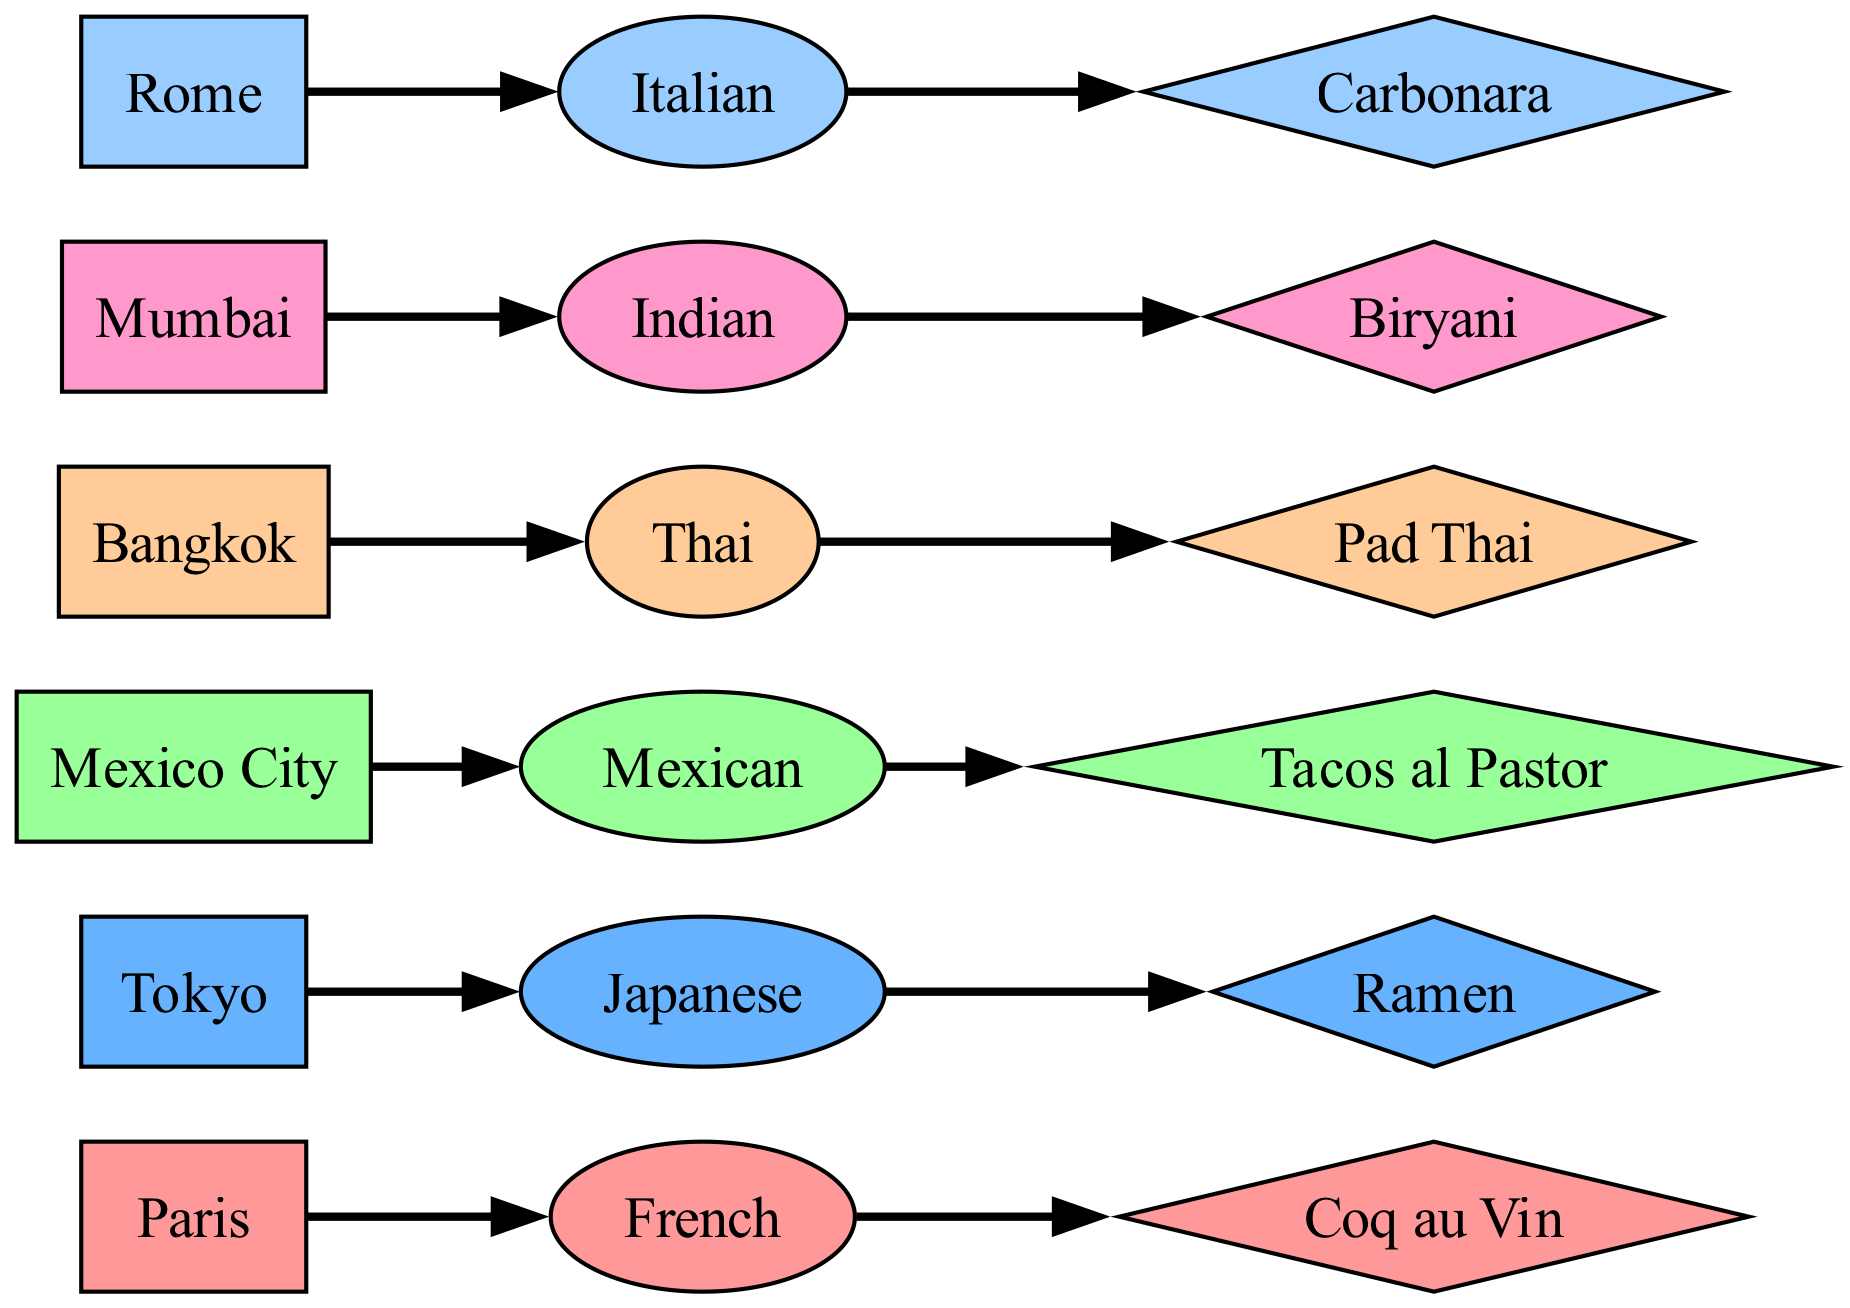What cuisine is represented in Tokyo? The diagram shows a link from Tokyo to the cuisine node labeled "Japanese," indicating that the cuisine represented in Tokyo is Japanese.
Answer: Japanese Which city is known for Coq au Vin? From the diagram, there is a direct connection from Paris to the favorite dish node labeled "Coq au Vin," indicating that Paris is associated with this dish.
Answer: Paris How many favorite dishes are represented in the diagram? By counting the number of favorite dish nodes (Coq au Vin, Ramen, Tacos al Pastor, Pad Thai, Biryani, Carbonara), we find there are six unique favorite dishes represented in the diagram.
Answer: 6 What is the favorite dish of Mumbai? The link between Mumbai and the favorite dish node shows the label "Biryani," indicating that the favorite dish in Mumbai is Biryani.
Answer: Biryani Which cuisine is connected to the favorite dish Pad Thai? The diagram illustrates a connection from the Thai cuisine node to the favorite dish node "Pad Thai," indicating that Pad Thai is the favorite dish related to Thai cuisine.
Answer: Thai Which two cuisines are most connected to favorite dishes in the diagram? Counting the connections leads to the conclusion that each cuisine node (French, Japanese, Mexican, Thai, Indian, Italian) has one connection to a favorite dish. Therefore, no cuisine is more connected than others; all have equal connections.
Answer: All equal How many edges are there in total in the diagram? Each city connects to a cuisine, and each cuisine connects to a favorite dish, making a total of six cities and connections to six cuisines and six favorite dishes. Thus, the number of edges is double the number of cities, resulting in twelve edges in total.
Answer: 12 What is the favorite dish in Rome? The diagram shows a direct link from Rome to the favorite dish node labeled "Carbonara," which indicates that the favorite dish in Rome is Carbonara.
Answer: Carbonara Which city’s cuisine is not represented in the diagram? Since the diagram includes Paris, Tokyo, Mexico City, Bangkok, Mumbai, and Rome, and there are no other cities represented, it follows that no other cities' cuisines are illustrated here. Therefore, cities like New York or London are not represented.
Answer: New York or London 